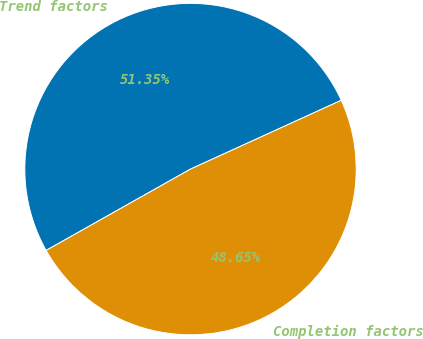Convert chart to OTSL. <chart><loc_0><loc_0><loc_500><loc_500><pie_chart><fcel>Trend factors<fcel>Completion factors<nl><fcel>51.35%<fcel>48.65%<nl></chart> 